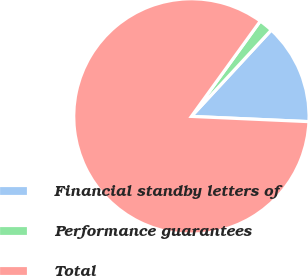<chart> <loc_0><loc_0><loc_500><loc_500><pie_chart><fcel>Financial standby letters of<fcel>Performance guarantees<fcel>Total<nl><fcel>13.83%<fcel>1.92%<fcel>84.25%<nl></chart> 